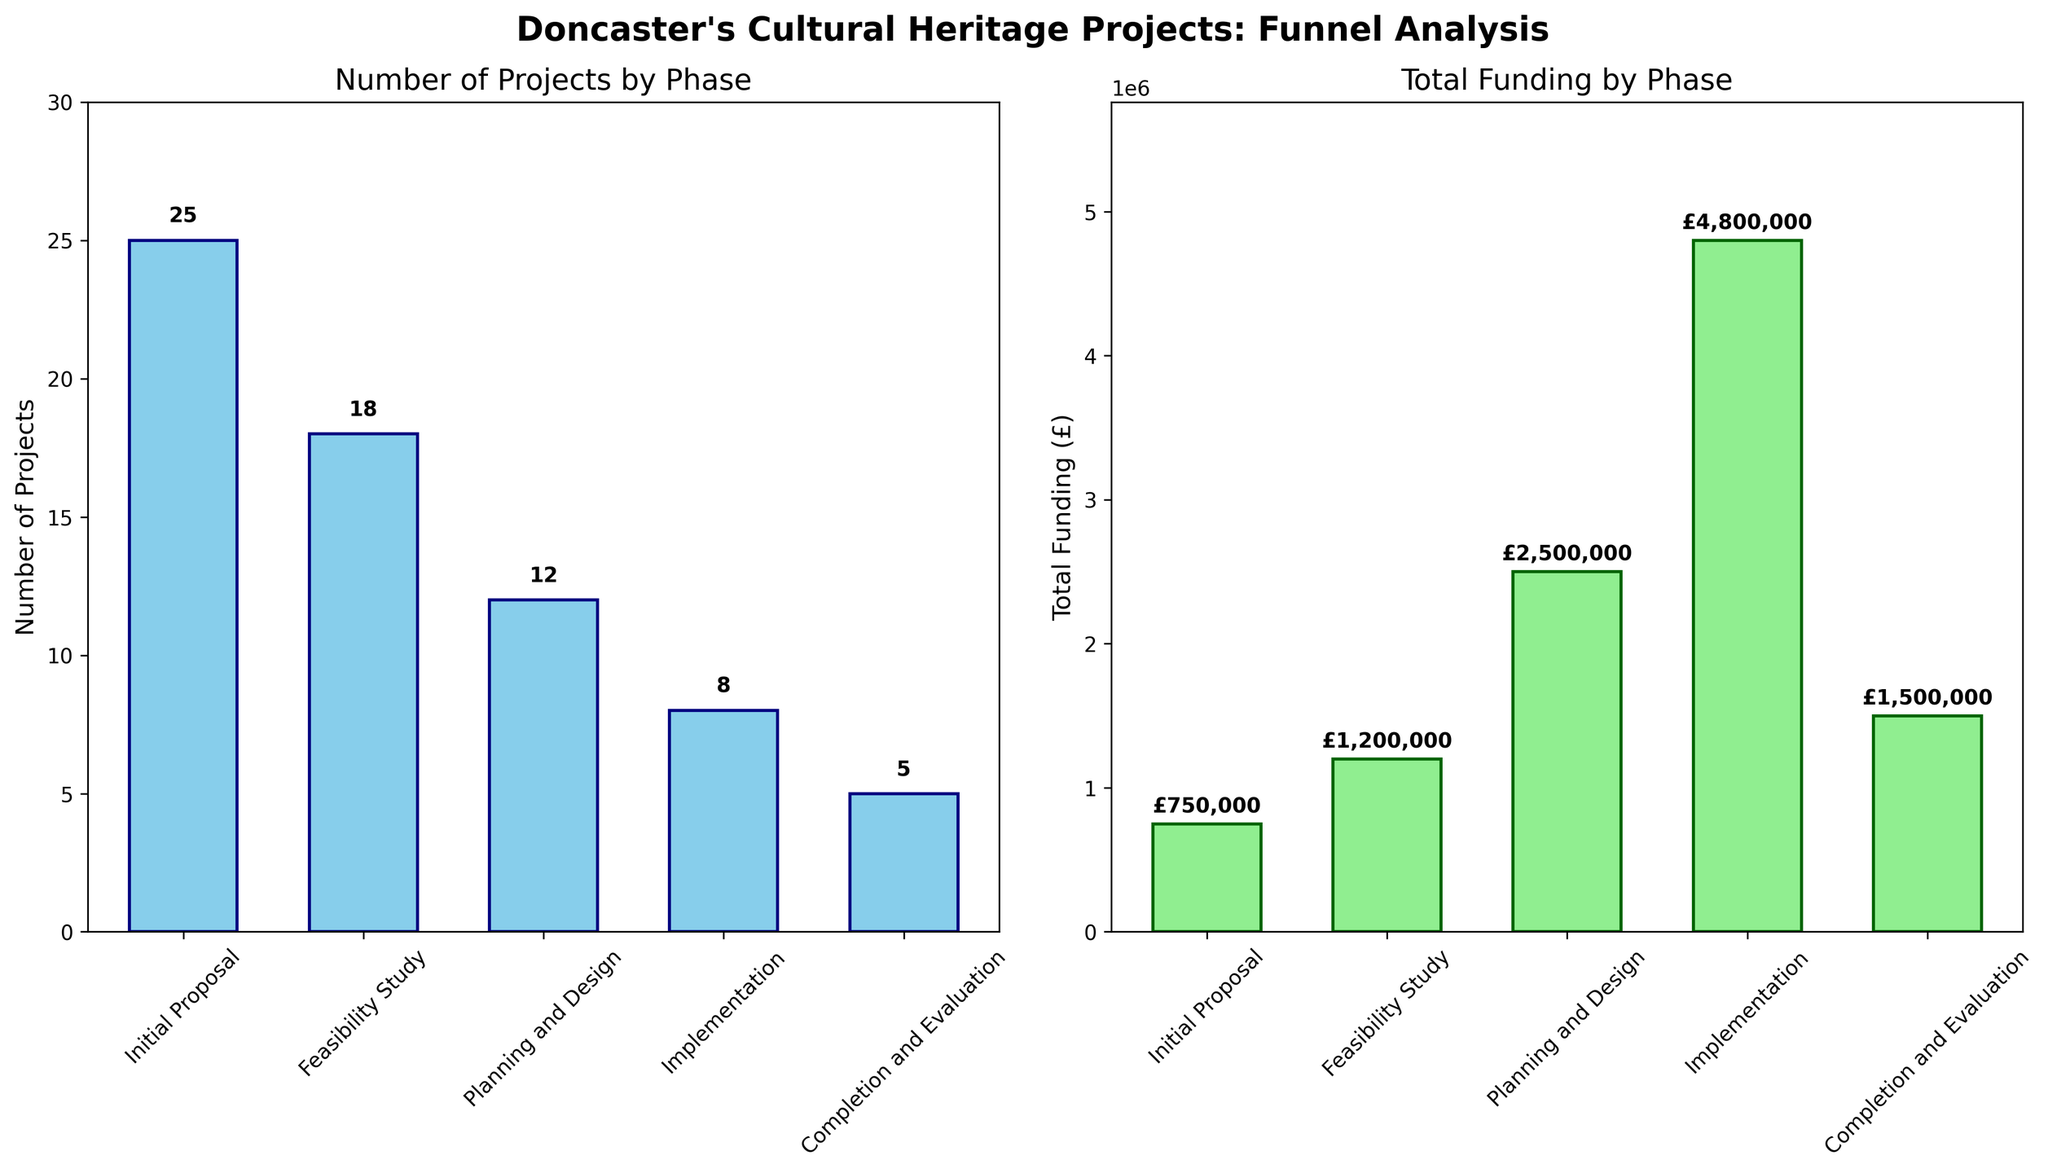what are the phases listed in the funnel charts? The phases listed in the funnel charts are shown on the x-axis of both bar charts. The phases are Initial Proposal, Feasibility Study, Planning and Design, Implementation, and Completion and Evaluation.
Answer: Initial Proposal, Feasibility Study, Planning and Design, Implementation, Completion and Evaluation How much total funding is allocated to the Implementation phase? The total funding allocated to each phase is given by the height of the bars in the right chart. The Implementation phase has a bar labeled £4,800,000.
Answer: £4,800,000 Which phase has the highest number of projects? The number of projects for each phase is depicted by the height of the bars in the left chart. The Initial Proposal phase has the highest bar with 25 projects.
Answer: Initial Proposal What is the ratio of total funding between the Implementation phase and the Feasibility Study phase? The total funding for the Implementation phase is £4,800,000 and for the Feasibility Study phase is £1,200,000. The ratio is calculated by dividing the funding of Implementation by Feasibility Study, so £4,800,000 / £1,200,000 = 4.
Answer: 4 How does the number of projects change from the Initial Proposal phase to the Completion and Evaluation phase? The number of projects decreases as they move from the Initial Proposal phase (25 projects) to the Feasibility Study (18), Planning and Design (12), Implementation (8) and finally Completion and Evaluation (5).
Answer: Decreases What is the average total funding across all phases? Sum the total funding for all the phases and divide by the number of phases. (£750,000 + £1,200,000 + £2,500,000 + £4,800,000 + £1,500,000) / 5 = £10,750,000 / 5 = £2,150,000
Answer: £2,150,000 Which phase has the lowest amount of total funding? The total funding for each phase is given by the height and label of the bars in the right chart. The Initial Proposal phase has the lowest total funding of £750,000.
Answer: Initial Proposal Compare the number of projects in the Feasibility Study phase to the Planning and Design phase. The Feasibility Study phase has 18 projects, and the Planning and Design phase has 12 projects. Therefore, the Feasibility Study phase has more projects.
Answer: Feasibility Study phase has more projects What percentage of projects reach the Implementation phase? To find the percentage of projects reaching the Implementation phase, divide the number of projects in the Implementation phase by the number in the Initial Proposal phase and multiply by 100. (8 / 25) * 100 = 32%
Answer: 32% How much more funding is allocated to the Planning and Design phase compared to the Initial Proposal phase? Subtract the total funding of the Initial Proposal phase from that of the Planning and Design phase. £2,500,000 - £750,000 = £1,750,000
Answer: £1,750,000 